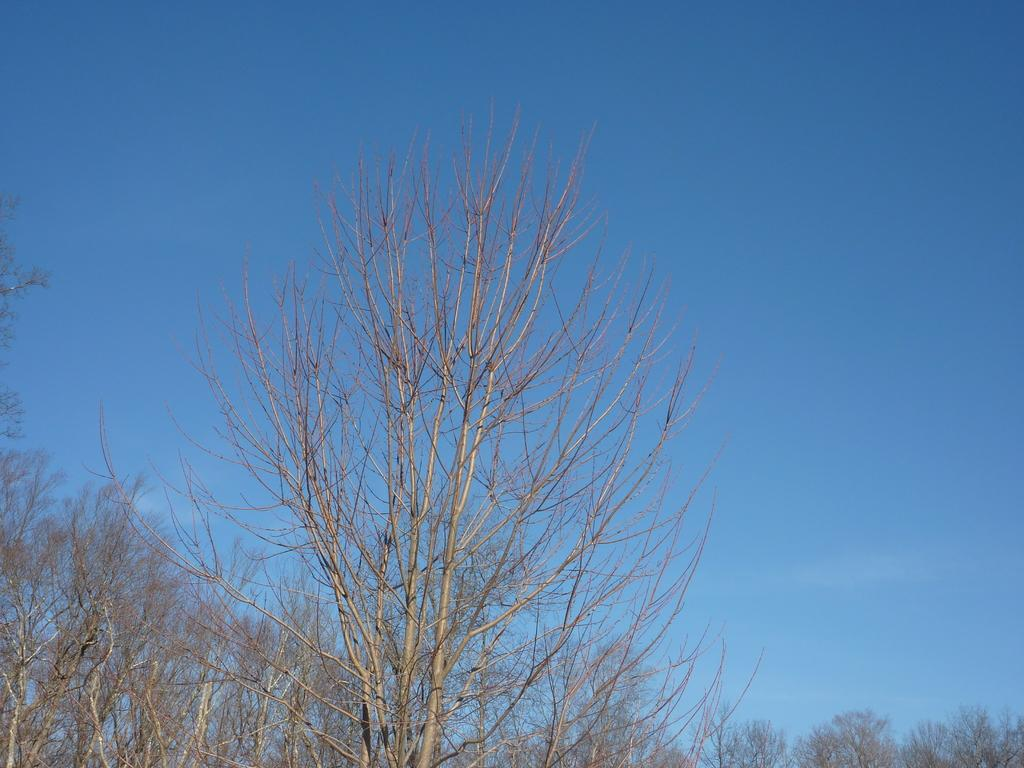What type of trees are visible in the image? There are dry trees in the image. What color is the sky in the background of the image? The sky is blue in the background of the image. What type of stage can be seen in the image? There is no stage present in the image; it features dry trees and a blue sky. How many people are laughing in the image? There are no people visible in the image, so it is not possible to determine how many might be laughing. 